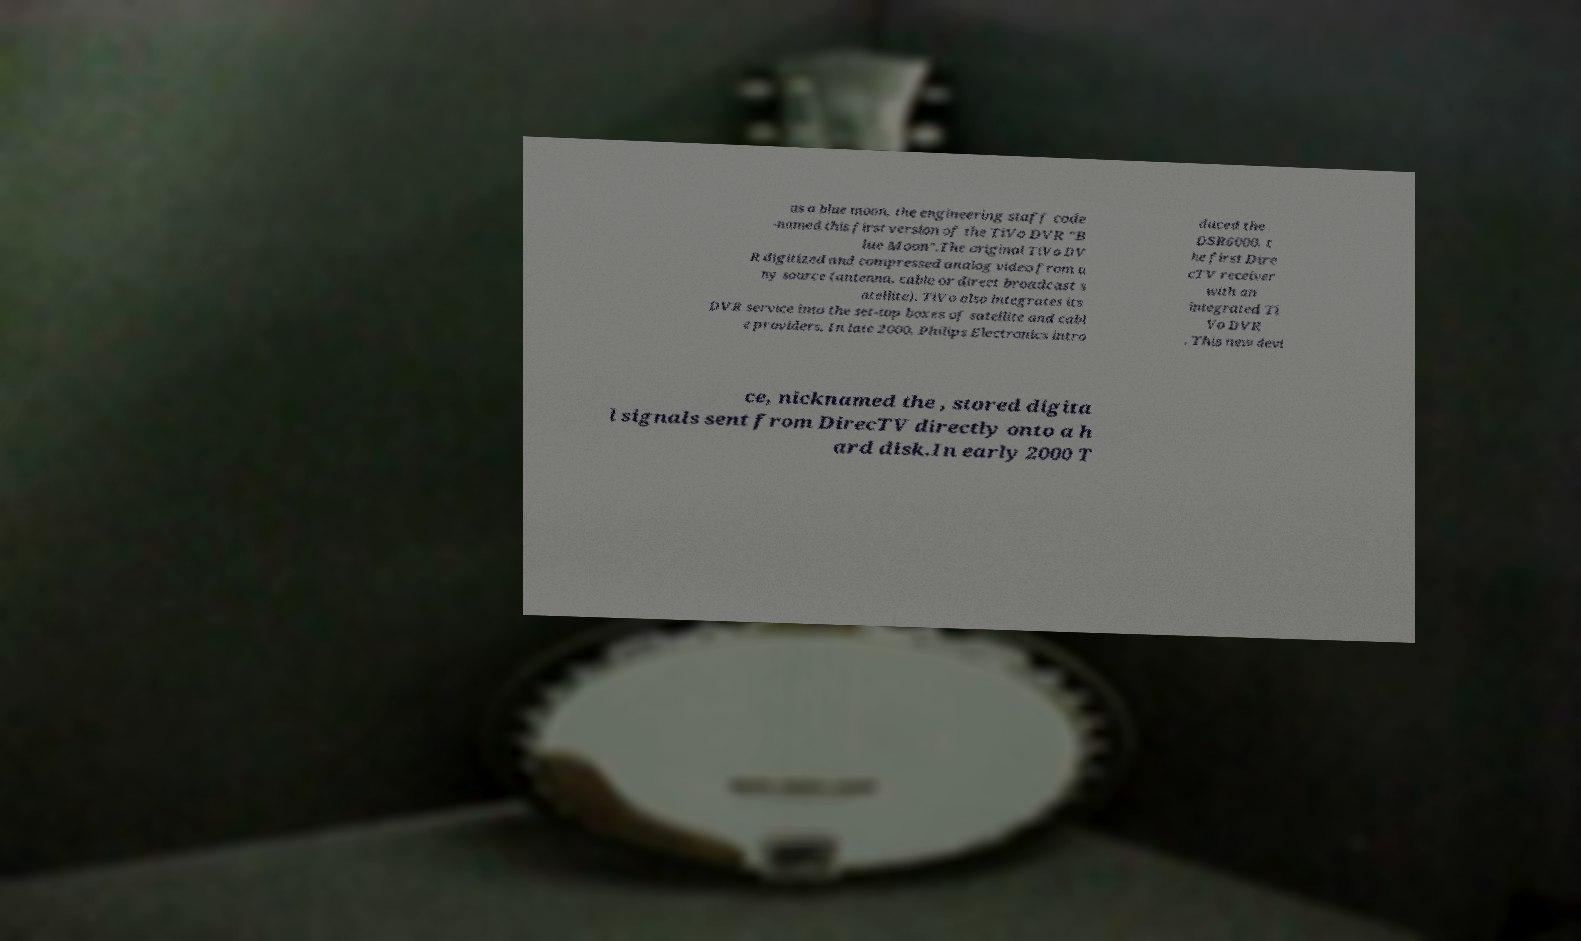Can you read and provide the text displayed in the image?This photo seems to have some interesting text. Can you extract and type it out for me? as a blue moon, the engineering staff code -named this first version of the TiVo DVR "B lue Moon".The original TiVo DV R digitized and compressed analog video from a ny source (antenna, cable or direct broadcast s atellite). TiVo also integrates its DVR service into the set-top boxes of satellite and cabl e providers. In late 2000, Philips Electronics intro duced the DSR6000, t he first Dire cTV receiver with an integrated Ti Vo DVR . This new devi ce, nicknamed the , stored digita l signals sent from DirecTV directly onto a h ard disk.In early 2000 T 